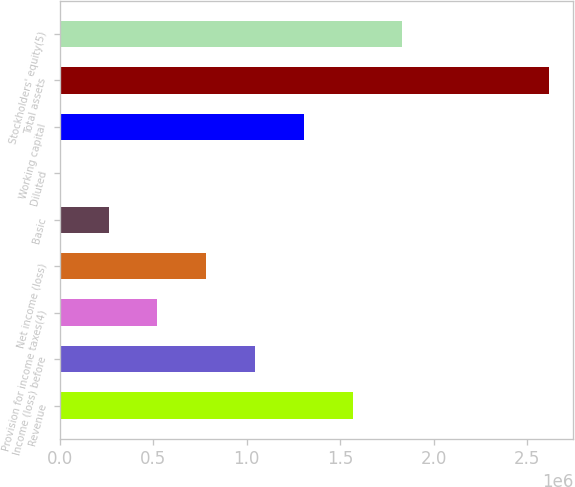Convert chart. <chart><loc_0><loc_0><loc_500><loc_500><bar_chart><fcel>Revenue<fcel>Income (loss) before<fcel>Provision for income taxes(4)<fcel>Net income (loss)<fcel>Basic<fcel>Diluted<fcel>Working capital<fcel>Total assets<fcel>Stockholders' equity(5)<nl><fcel>1.5704e+06<fcel>1.04694e+06<fcel>523468<fcel>785202<fcel>261734<fcel>0.87<fcel>1.30867e+06<fcel>2.61734e+06<fcel>1.83214e+06<nl></chart> 